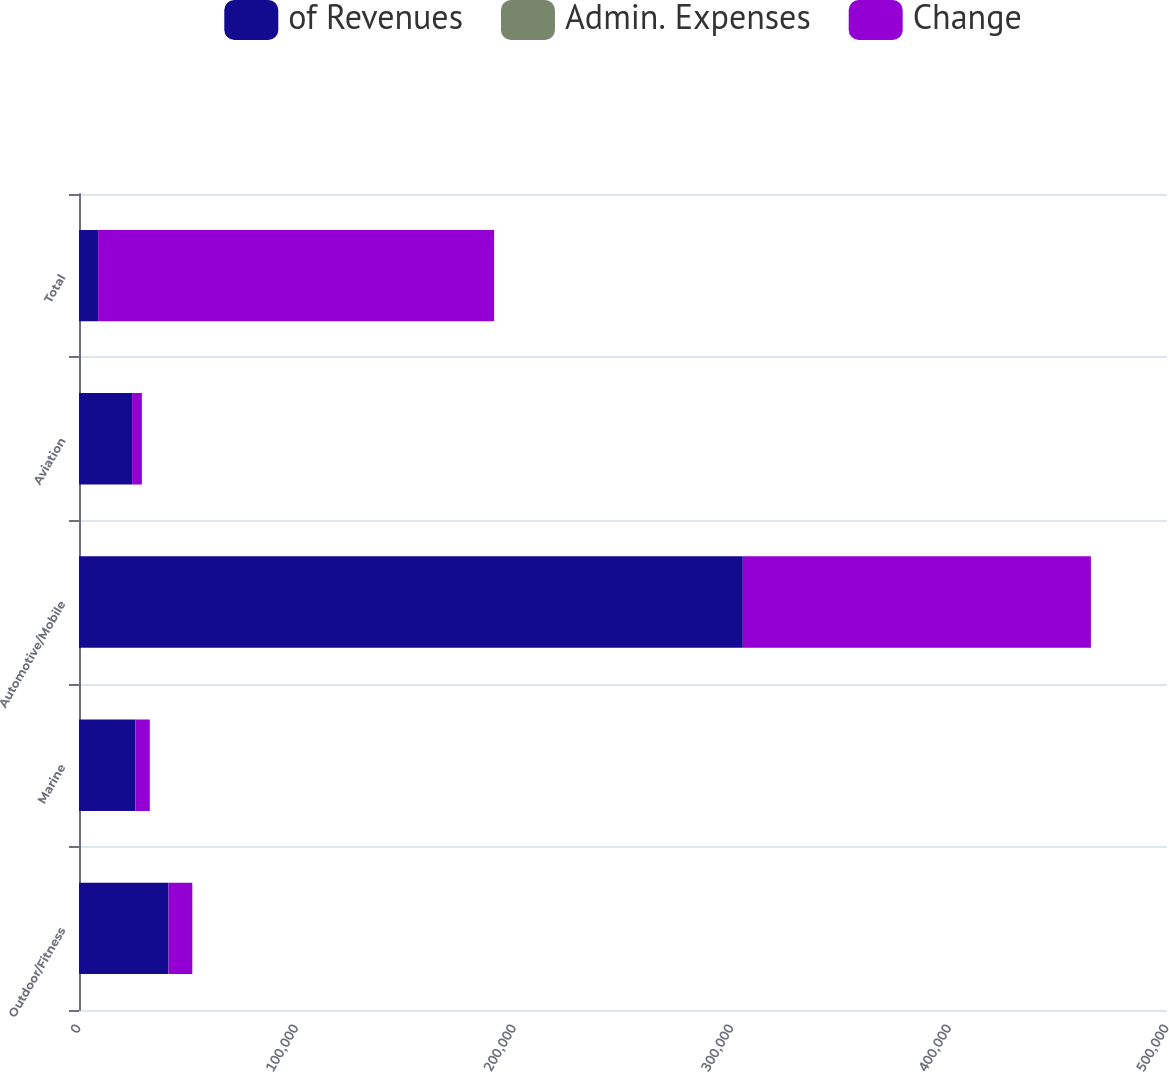Convert chart. <chart><loc_0><loc_0><loc_500><loc_500><stacked_bar_chart><ecel><fcel>Outdoor/Fitness<fcel>Marine<fcel>Automotive/Mobile<fcel>Aviation<fcel>Total<nl><fcel>of Revenues<fcel>41119<fcel>25914<fcel>305065<fcel>24400<fcel>8775<nl><fcel>Admin. Expenses<fcel>12.1<fcel>12.7<fcel>13<fcel>8.3<fcel>12.5<nl><fcel>Change<fcel>10943<fcel>6607<fcel>159952<fcel>4483<fcel>181985<nl></chart> 